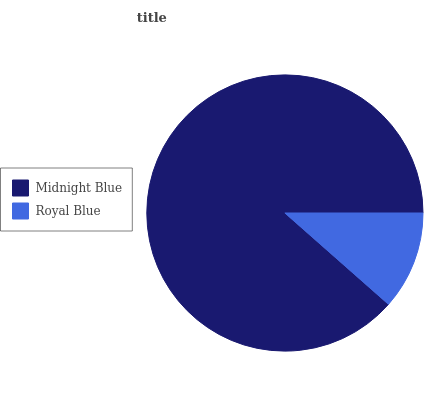Is Royal Blue the minimum?
Answer yes or no. Yes. Is Midnight Blue the maximum?
Answer yes or no. Yes. Is Royal Blue the maximum?
Answer yes or no. No. Is Midnight Blue greater than Royal Blue?
Answer yes or no. Yes. Is Royal Blue less than Midnight Blue?
Answer yes or no. Yes. Is Royal Blue greater than Midnight Blue?
Answer yes or no. No. Is Midnight Blue less than Royal Blue?
Answer yes or no. No. Is Midnight Blue the high median?
Answer yes or no. Yes. Is Royal Blue the low median?
Answer yes or no. Yes. Is Royal Blue the high median?
Answer yes or no. No. Is Midnight Blue the low median?
Answer yes or no. No. 